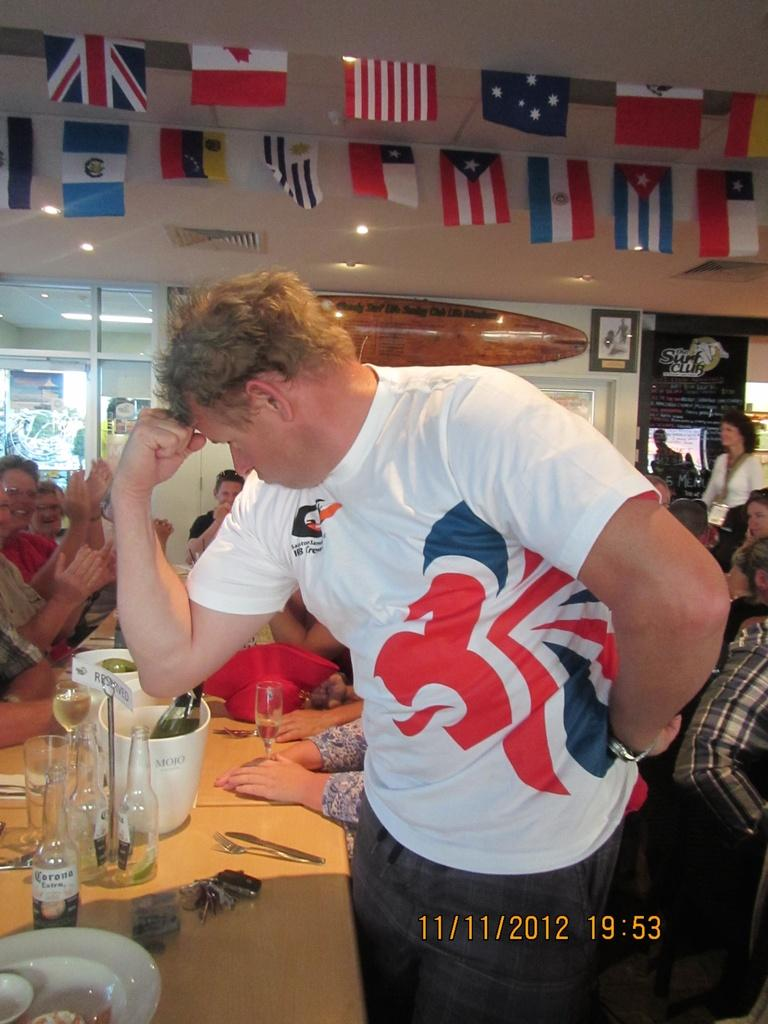Provide a one-sentence caption for the provided image. A man flexes his right arm in an image dated 11/11/2012. 